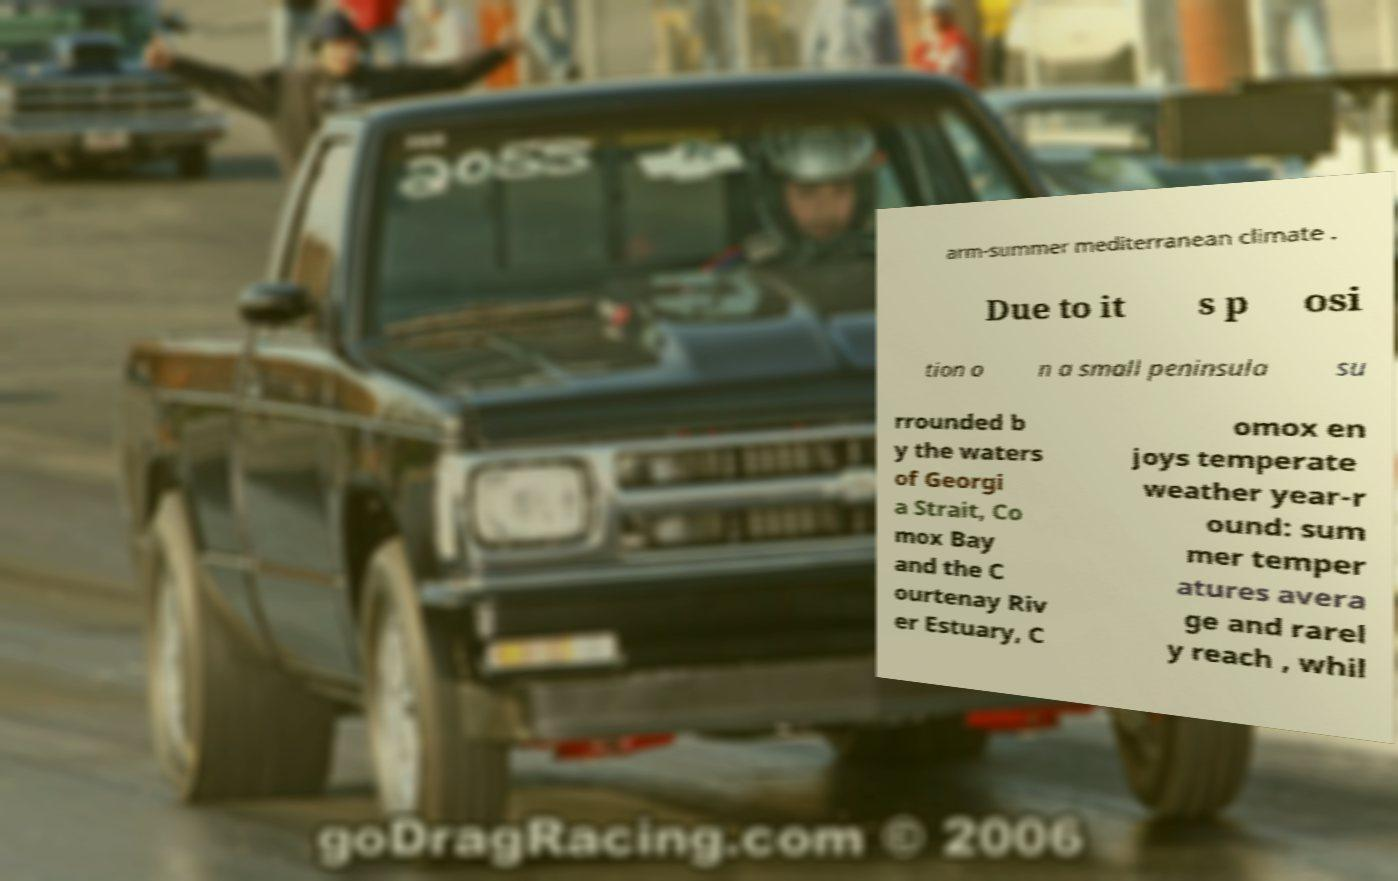Could you extract and type out the text from this image? arm-summer mediterranean climate . Due to it s p osi tion o n a small peninsula su rrounded b y the waters of Georgi a Strait, Co mox Bay and the C ourtenay Riv er Estuary, C omox en joys temperate weather year-r ound: sum mer temper atures avera ge and rarel y reach , whil 